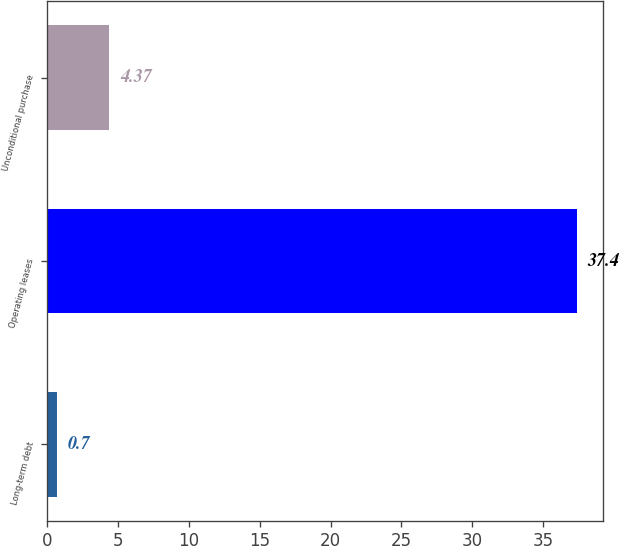<chart> <loc_0><loc_0><loc_500><loc_500><bar_chart><fcel>Long-term debt<fcel>Operating leases<fcel>Unconditional purchase<nl><fcel>0.7<fcel>37.4<fcel>4.37<nl></chart> 